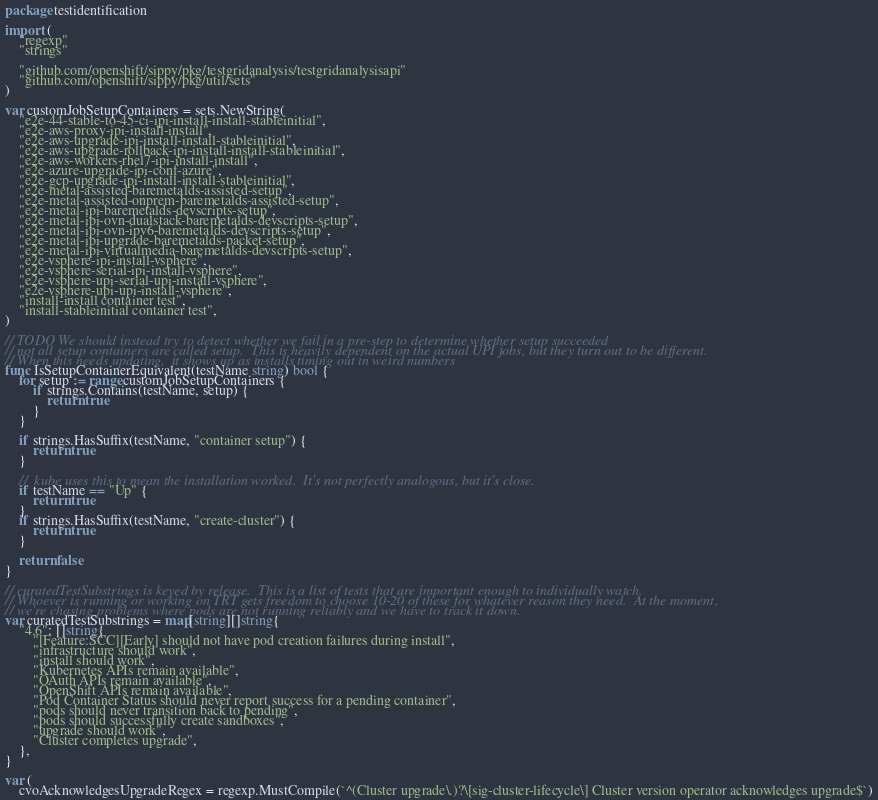Convert code to text. <code><loc_0><loc_0><loc_500><loc_500><_Go_>package testidentification

import (
	"regexp"
	"strings"

	"github.com/openshift/sippy/pkg/testgridanalysis/testgridanalysisapi"
	"github.com/openshift/sippy/pkg/util/sets"
)

var customJobSetupContainers = sets.NewString(
	"e2e-44-stable-to-45-ci-ipi-install-install-stableinitial",
	"e2e-aws-proxy-ipi-install-install",
	"e2e-aws-upgrade-ipi-install-install-stableinitial",
	"e2e-aws-upgrade-rollback-ipi-install-install-stableinitial",
	"e2e-aws-workers-rhel7-ipi-install-install",
	"e2e-azure-upgrade-ipi-conf-azure",
	"e2e-gcp-upgrade-ipi-install-install-stableinitial",
	"e2e-metal-assisted-baremetalds-assisted-setup",
	"e2e-metal-assisted-onprem-baremetalds-assisted-setup",
	"e2e-metal-ipi-baremetalds-devscripts-setup",
	"e2e-metal-ipi-ovn-dualstack-baremetalds-devscripts-setup",
	"e2e-metal-ipi-ovn-ipv6-baremetalds-devscripts-setup",
	"e2e-metal-ipi-upgrade-baremetalds-packet-setup",
	"e2e-metal-ipi-virtualmedia-baremetalds-devscripts-setup",
	"e2e-vsphere-ipi-install-vsphere",
	"e2e-vsphere-serial-ipi-install-vsphere",
	"e2e-vsphere-upi-serial-upi-install-vsphere",
	"e2e-vsphere-upi-upi-install-vsphere",
	"install-install container test",
	"install-stableinitial container test",
)

// TODO We should instead try to detect whether we fail in a pre-step to determine whether setup succeeded
// not all setup containers are called setup.  This is heavily dependent on the actual UPI jobs, but they turn out to be different.
// When this needs updating,  it shows up as installs timing out in weird numbers
func IsSetupContainerEquivalent(testName string) bool {
	for setup := range customJobSetupContainers {
		if strings.Contains(testName, setup) {
			return true
		}
	}

	if strings.HasSuffix(testName, "container setup") {
		return true
	}

	//  kube uses this to mean the installation worked.  It's not perfectly analogous, but it's close.
	if testName == "Up" {
		return true
	}
	if strings.HasSuffix(testName, "create-cluster") {
		return true
	}

	return false
}

// curatedTestSubstrings is keyed by release.  This is a list of tests that are important enough to individually watch.
// Whoever is running or working on TRT gets freedom to choose 10-20 of these for whatever reason they need.  At the moment,
// we're chasing problems where pods are not running reliably and we have to track it down.
var curatedTestSubstrings = map[string][]string{
	"4.6": []string{
		"[Feature:SCC][Early] should not have pod creation failures during install",
		"infrastructure should work",
		"install should work",
		"Kubernetes APIs remain available",
		"OAuth APIs remain available",
		"OpenShift APIs remain available",
		"Pod Container Status should never report success for a pending container",
		"pods should never transition back to pending",
		"pods should successfully create sandboxes",
		"upgrade should work",
		"Cluster completes upgrade",
	},
}

var (
	cvoAcknowledgesUpgradeRegex = regexp.MustCompile(`^(Cluster upgrade\.)?\[sig-cluster-lifecycle\] Cluster version operator acknowledges upgrade$`)</code> 